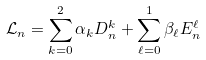Convert formula to latex. <formula><loc_0><loc_0><loc_500><loc_500>\mathcal { L } _ { n } = \sum _ { k = 0 } ^ { 2 } \alpha _ { k } D ^ { k } _ { n } + \sum _ { \ell = 0 } ^ { 1 } \beta _ { \ell } E ^ { \ell } _ { n }</formula> 